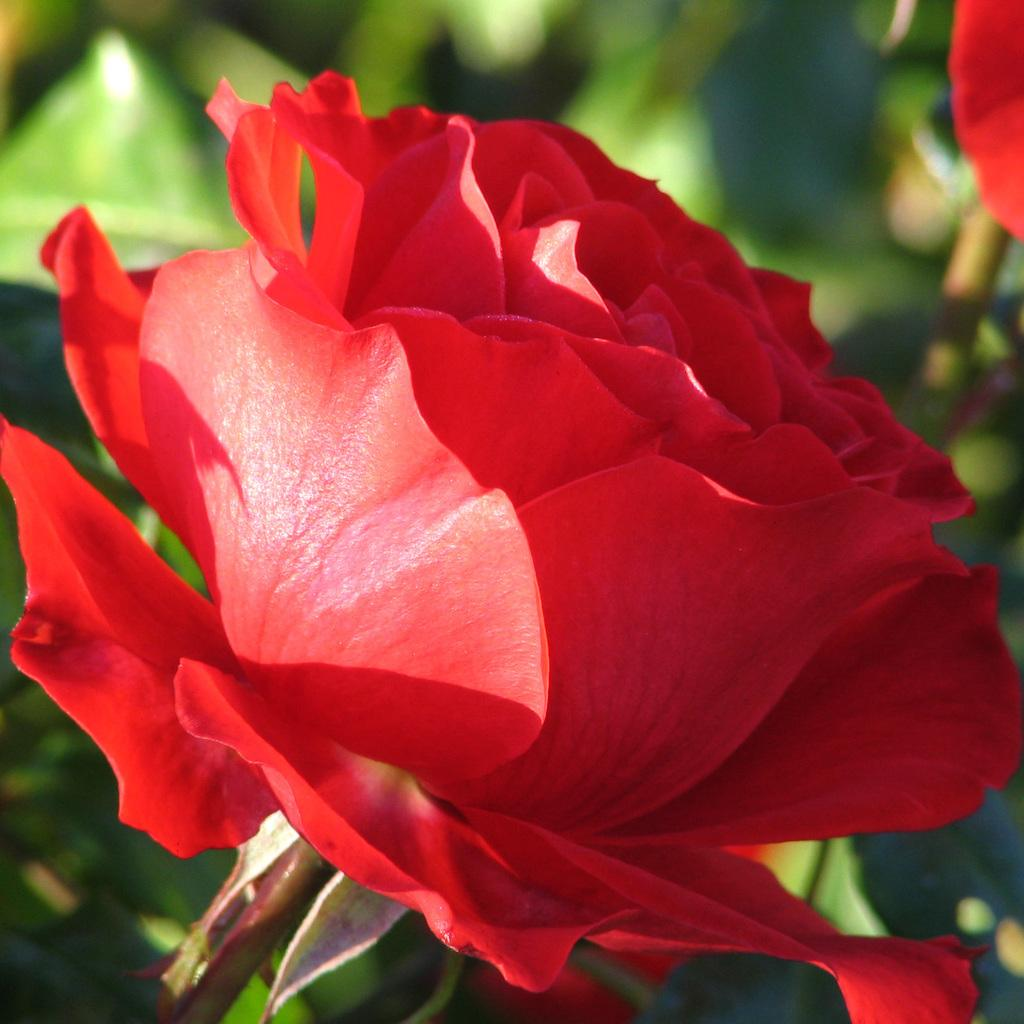What is the main subject in the middle of the image? There is a red rose in the middle of the image. What can be seen in the background of the image? There are plants in the background of the image. Are there any other flowers visible in the image? Yes, there is another rose in the background of the image. What type of chess piece is located on the left side of the image? There is no chess piece present in the image; it features a red rose and plants in the background. What color is the person's hair in the image? There are no people or hair visible in the image. 